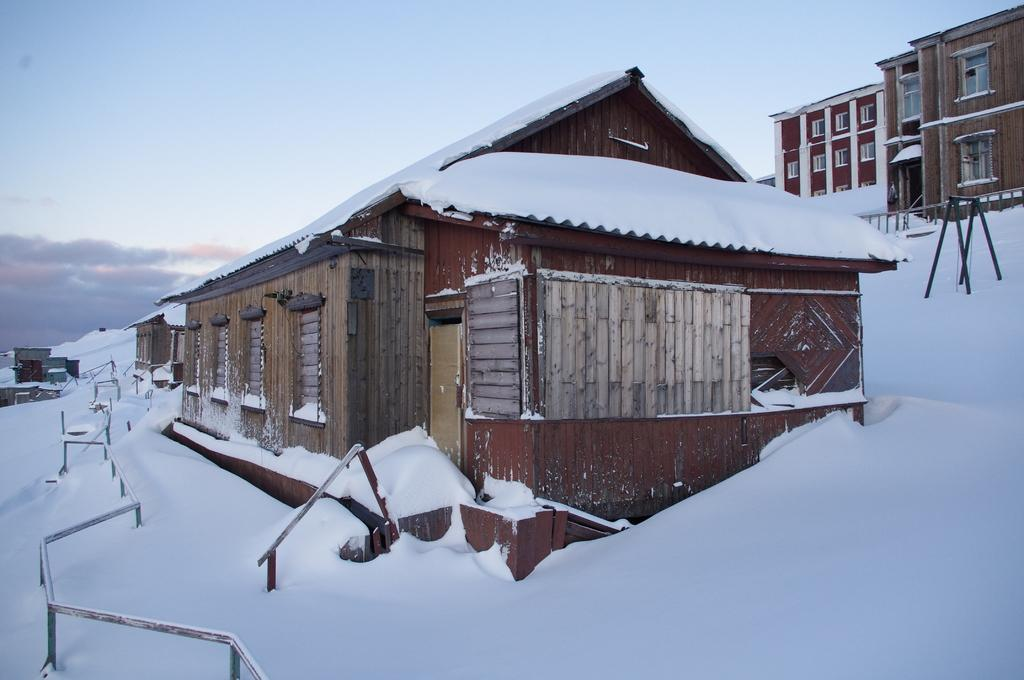What type of structures can be seen in the image? There are houses in the image. How are the houses affected by the weather? The houses are covered with snow. What can be seen in the background of the image? The sky is visible in the background of the image. What colors are present in the sky? The sky has a combination of white and blue colors. What objects can be seen in the distance in the image? There are poles in the background of the image. What type of stocking is hanging from the chimney of the houses in the image? There is no stocking hanging from the chimney of the houses in the image; it is covered with snow. What type of stone is present in the image? There is no stone present in the image; it features houses covered with snow and a background with sky and poles. 